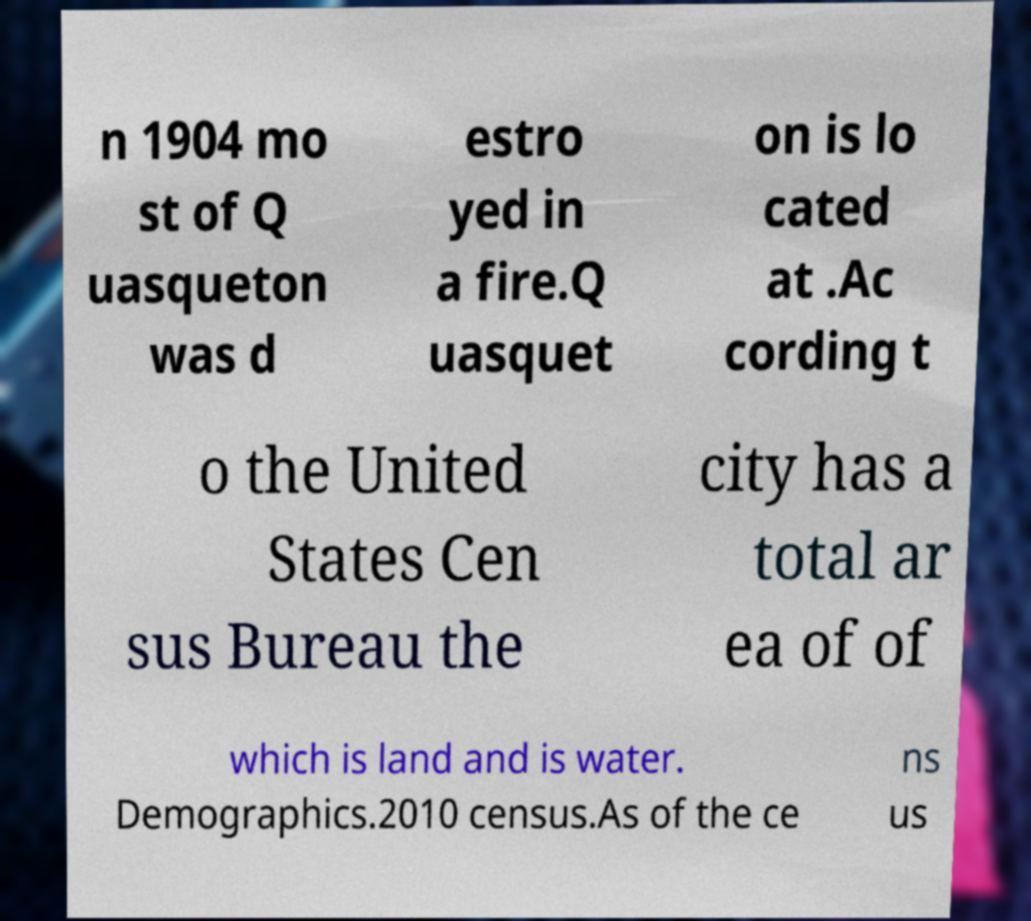What messages or text are displayed in this image? I need them in a readable, typed format. n 1904 mo st of Q uasqueton was d estro yed in a fire.Q uasquet on is lo cated at .Ac cording t o the United States Cen sus Bureau the city has a total ar ea of of which is land and is water. Demographics.2010 census.As of the ce ns us 